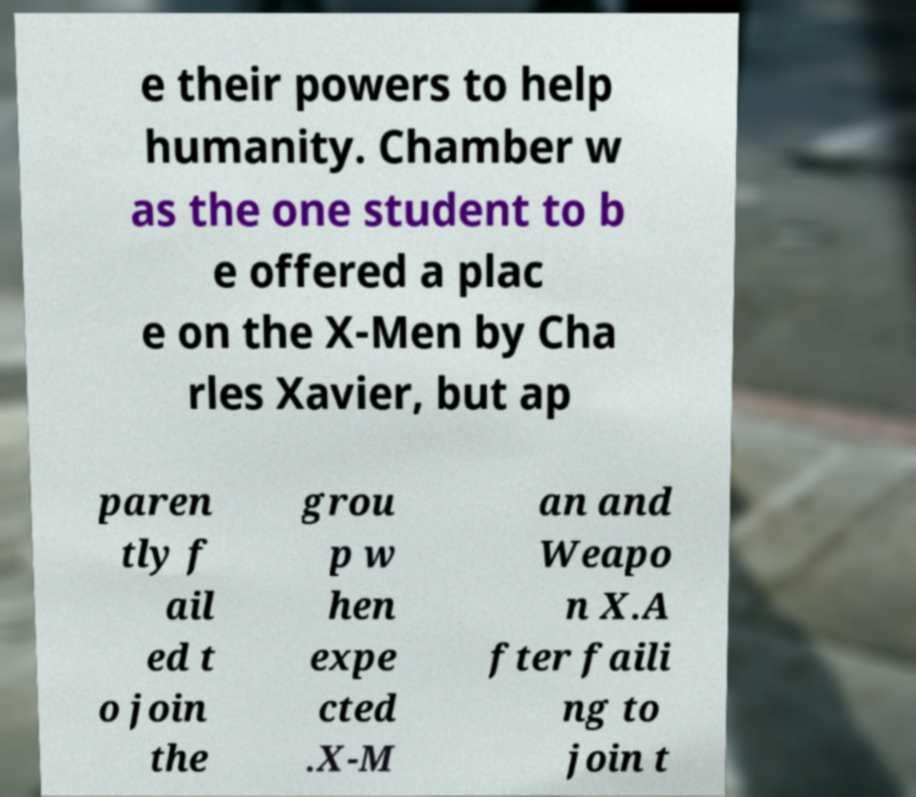Could you assist in decoding the text presented in this image and type it out clearly? e their powers to help humanity. Chamber w as the one student to b e offered a plac e on the X-Men by Cha rles Xavier, but ap paren tly f ail ed t o join the grou p w hen expe cted .X-M an and Weapo n X.A fter faili ng to join t 